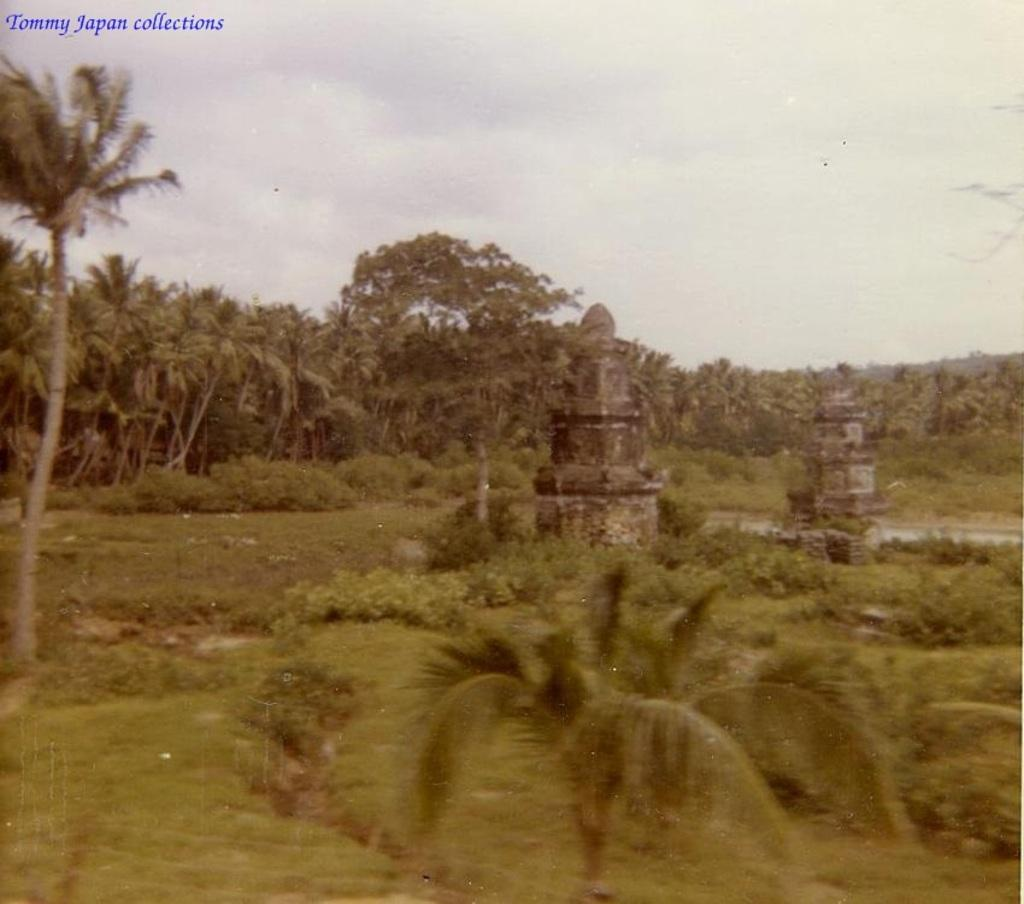What type of vegetation can be seen in the image? There are trees and plants in the image. What structures are present on the surface in the image? There are two pillars on the surface in the image. What is visible in the background of the image? The sky is visible in the image. Can you tell me how many baseballs are hanging from the trees in the image? There are no baseballs present in the image; it features trees, plants, and pillars. What type of screw is used to hold the pillars together in the image? There is no information about screws or how the pillars are held together in the image. 